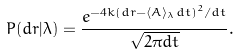Convert formula to latex. <formula><loc_0><loc_0><loc_500><loc_500>P ( d r | \lambda ) = \frac { e ^ { - 4 k ( d r - \langle A \rangle _ { \lambda } d t ) ^ { 2 } / d t } } { \sqrt { 2 \pi d t } } .</formula> 